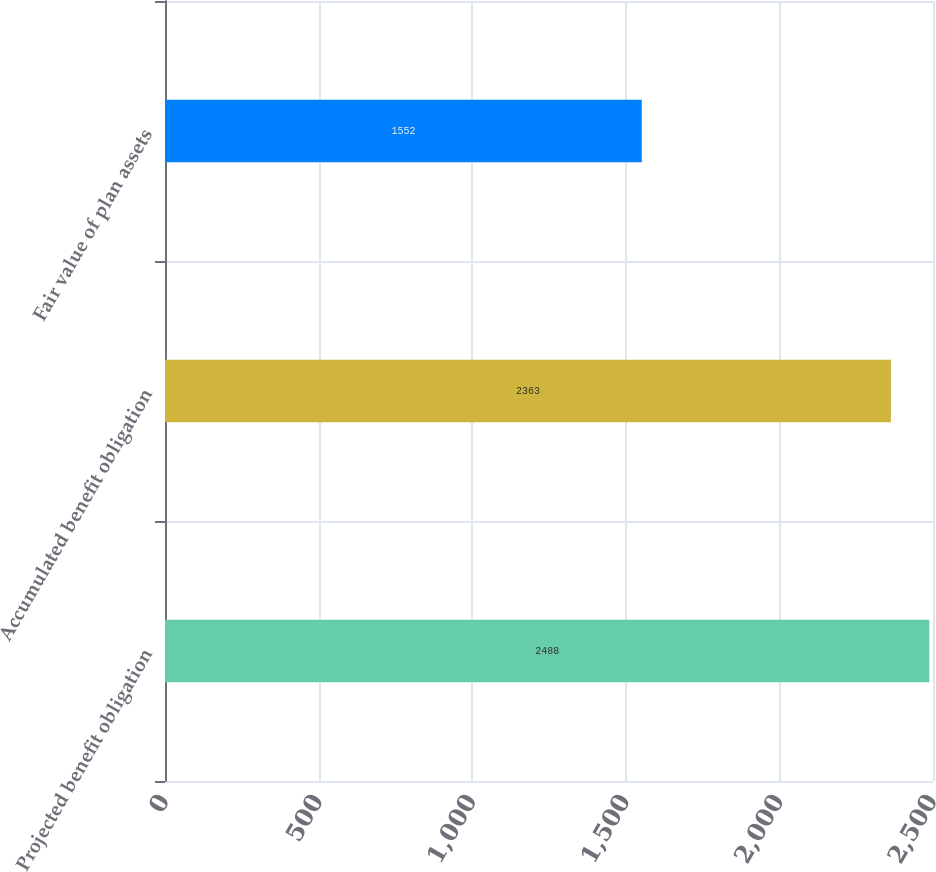<chart> <loc_0><loc_0><loc_500><loc_500><bar_chart><fcel>Projected benefit obligation<fcel>Accumulated benefit obligation<fcel>Fair value of plan assets<nl><fcel>2488<fcel>2363<fcel>1552<nl></chart> 